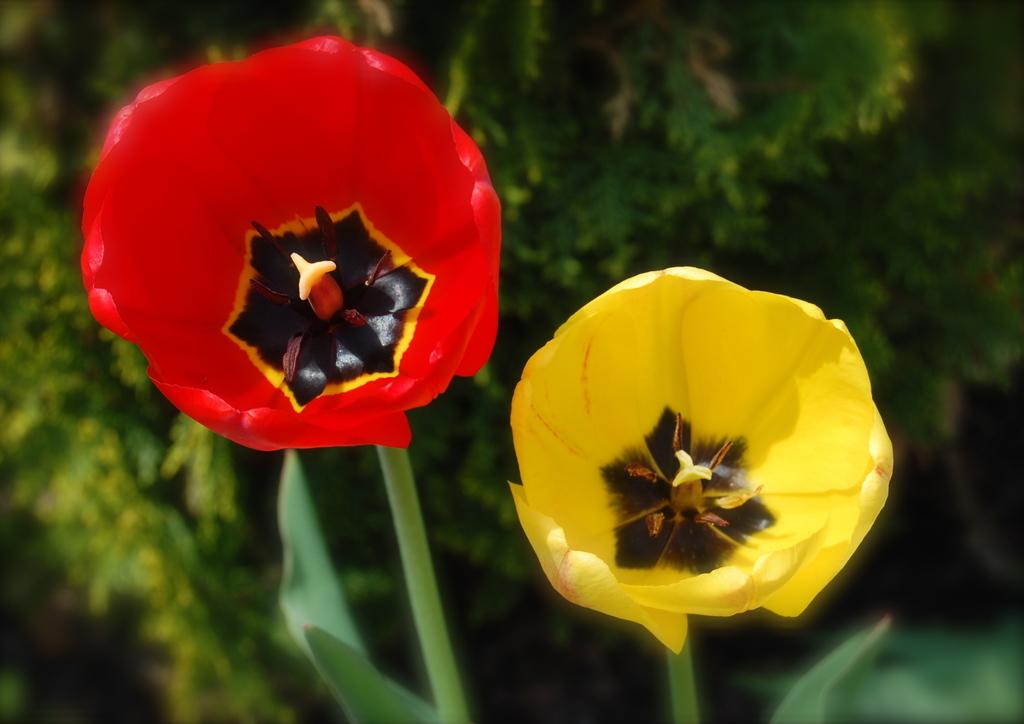What type of flowers can be seen in the image? There is a yellow flower on the right side of the image and a red flower on the left side of the image. What color is the background of the image? The background of the image is green in color. What type of discussion is taking place in the image? There is no discussion taking place in the image; it features flowers and a green background. Can you see any marbles in the image? There are no marbles present in the image. 